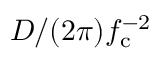<formula> <loc_0><loc_0><loc_500><loc_500>D / ( 2 \pi ) f _ { c } ^ { - 2 }</formula> 